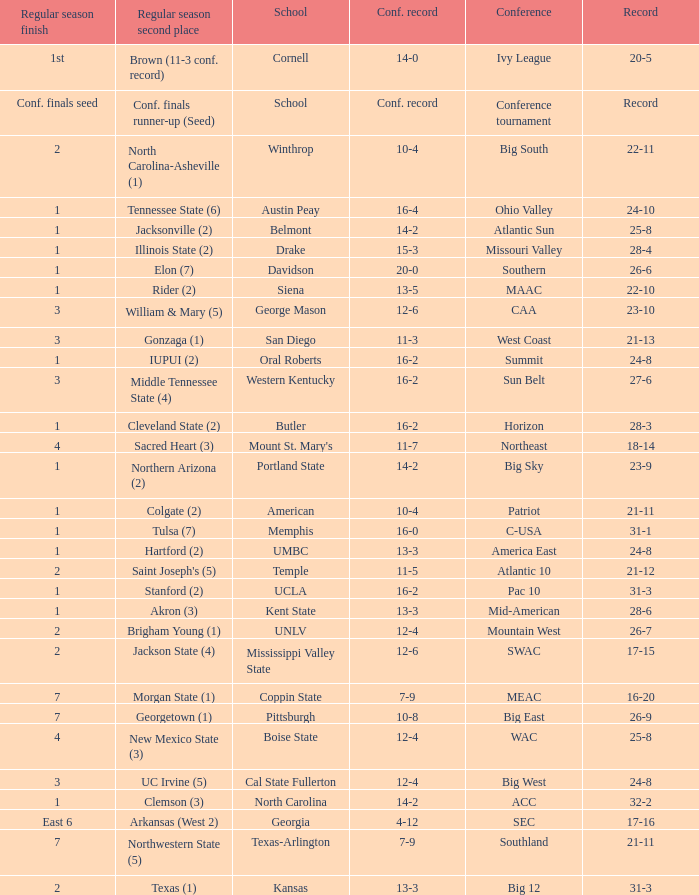What was the overall record of Oral Roberts college? 24-8. 